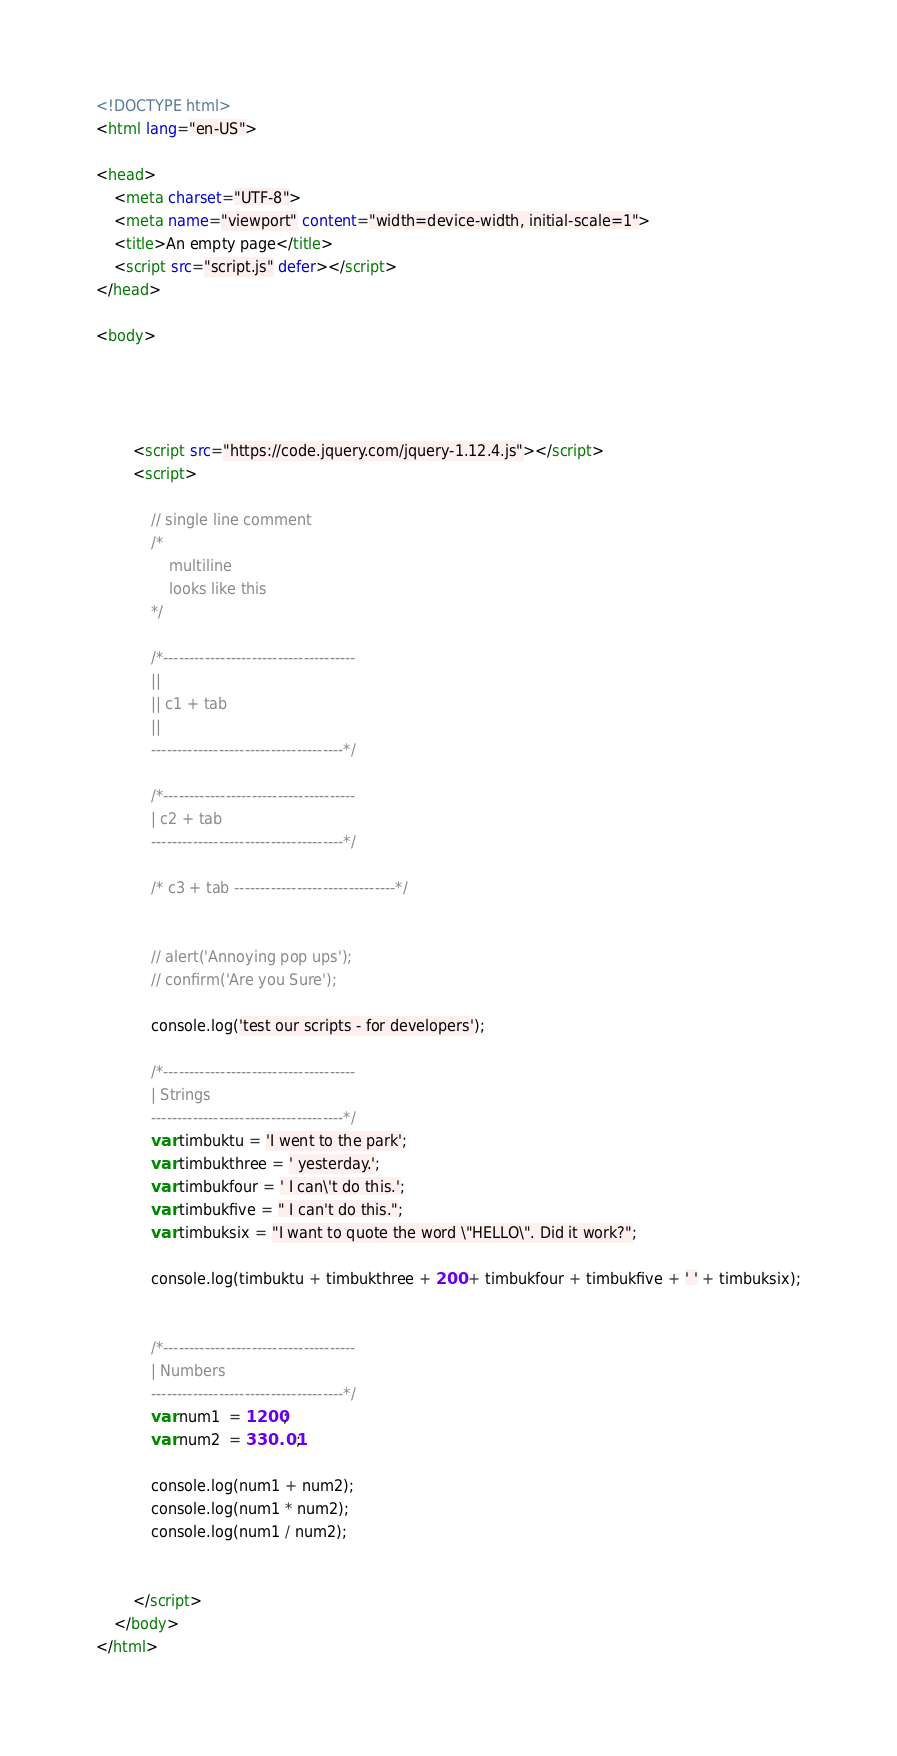<code> <loc_0><loc_0><loc_500><loc_500><_HTML_><!DOCTYPE html>
<html lang="en-US">

<head>
    <meta charset="UTF-8">
    <meta name="viewport" content="width=device-width, initial-scale=1">
    <title>An empty page</title>
    <script src="script.js" defer></script>
</head>

<body>




		<script src="https://code.jquery.com/jquery-1.12.4.js"></script>
		<script>

			// single line comment
			/*
				multiline
				looks like this
			*/

			/*-------------------------------------
			||
			|| c1 + tab
			||
			-------------------------------------*/

			/*-------------------------------------
			| c2 + tab
			-------------------------------------*/

			/* c3 + tab -------------------------------*/


			// alert('Annoying pop ups');
			// confirm('Are you Sure');

			console.log('test our scripts - for developers');

			/*-------------------------------------
			| Strings
			-------------------------------------*/
			var timbuktu = 'I went to the park';
			var timbukthree = ' yesterday.';
			var timbukfour = ' I can\'t do this.';
			var timbukfive = " I can't do this.";
			var timbuksix = "I want to quote the word \"HELLO\". Did it work?";

			console.log(timbuktu + timbukthree + 200 + timbukfour + timbukfive + ' ' + timbuksix);


			/*-------------------------------------
			| Numbers
			-------------------------------------*/
			var num1  = 1200;
			var num2  = 330.01;

			console.log(num1 + num2);
			console.log(num1 * num2);
			console.log(num1 / num2);


		</script>
	</body>
</html>
</code> 